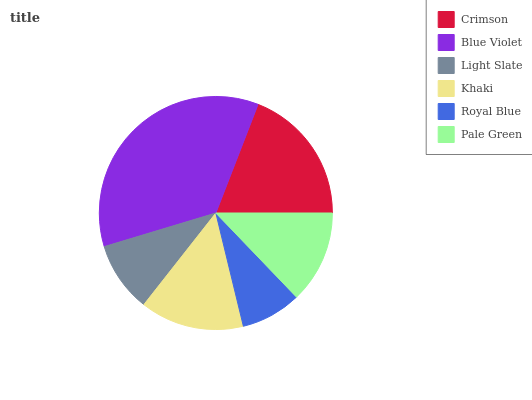Is Royal Blue the minimum?
Answer yes or no. Yes. Is Blue Violet the maximum?
Answer yes or no. Yes. Is Light Slate the minimum?
Answer yes or no. No. Is Light Slate the maximum?
Answer yes or no. No. Is Blue Violet greater than Light Slate?
Answer yes or no. Yes. Is Light Slate less than Blue Violet?
Answer yes or no. Yes. Is Light Slate greater than Blue Violet?
Answer yes or no. No. Is Blue Violet less than Light Slate?
Answer yes or no. No. Is Khaki the high median?
Answer yes or no. Yes. Is Pale Green the low median?
Answer yes or no. Yes. Is Crimson the high median?
Answer yes or no. No. Is Khaki the low median?
Answer yes or no. No. 